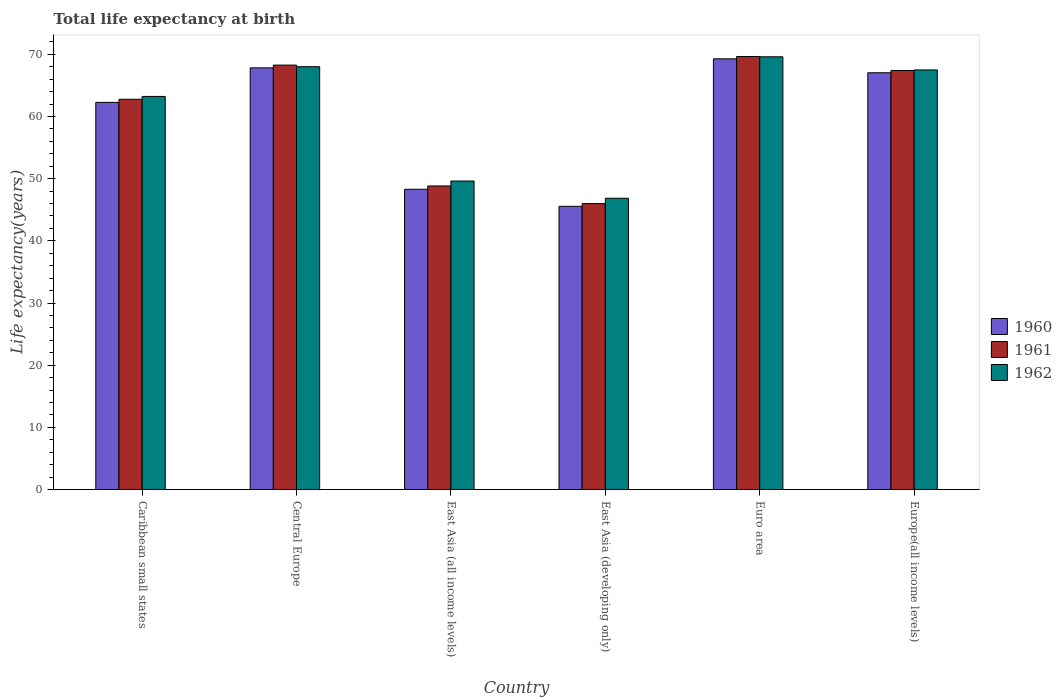Are the number of bars per tick equal to the number of legend labels?
Give a very brief answer. Yes. How many bars are there on the 4th tick from the left?
Offer a very short reply. 3. What is the label of the 2nd group of bars from the left?
Your answer should be compact. Central Europe. What is the life expectancy at birth in in 1961 in Euro area?
Give a very brief answer. 69.64. Across all countries, what is the maximum life expectancy at birth in in 1960?
Give a very brief answer. 69.27. Across all countries, what is the minimum life expectancy at birth in in 1962?
Offer a terse response. 46.85. In which country was the life expectancy at birth in in 1961 maximum?
Provide a short and direct response. Euro area. In which country was the life expectancy at birth in in 1961 minimum?
Keep it short and to the point. East Asia (developing only). What is the total life expectancy at birth in in 1962 in the graph?
Offer a terse response. 364.8. What is the difference between the life expectancy at birth in in 1960 in Caribbean small states and that in East Asia (developing only)?
Ensure brevity in your answer.  16.72. What is the difference between the life expectancy at birth in in 1961 in East Asia (all income levels) and the life expectancy at birth in in 1962 in Euro area?
Offer a very short reply. -20.78. What is the average life expectancy at birth in in 1962 per country?
Your answer should be compact. 60.8. What is the difference between the life expectancy at birth in of/in 1960 and life expectancy at birth in of/in 1961 in East Asia (developing only)?
Provide a succinct answer. -0.44. What is the ratio of the life expectancy at birth in in 1961 in Caribbean small states to that in Europe(all income levels)?
Offer a terse response. 0.93. Is the life expectancy at birth in in 1961 in East Asia (all income levels) less than that in Europe(all income levels)?
Your answer should be very brief. Yes. Is the difference between the life expectancy at birth in in 1960 in Caribbean small states and Euro area greater than the difference between the life expectancy at birth in in 1961 in Caribbean small states and Euro area?
Keep it short and to the point. No. What is the difference between the highest and the second highest life expectancy at birth in in 1962?
Offer a terse response. -0.52. What is the difference between the highest and the lowest life expectancy at birth in in 1961?
Keep it short and to the point. 23.66. In how many countries, is the life expectancy at birth in in 1960 greater than the average life expectancy at birth in in 1960 taken over all countries?
Your answer should be very brief. 4. Is the sum of the life expectancy at birth in in 1960 in East Asia (all income levels) and East Asia (developing only) greater than the maximum life expectancy at birth in in 1961 across all countries?
Provide a short and direct response. Yes. What does the 1st bar from the left in East Asia (all income levels) represents?
Ensure brevity in your answer.  1960. What does the 3rd bar from the right in East Asia (developing only) represents?
Give a very brief answer. 1960. How many bars are there?
Make the answer very short. 18. Are all the bars in the graph horizontal?
Your answer should be compact. No. Where does the legend appear in the graph?
Offer a terse response. Center right. How many legend labels are there?
Keep it short and to the point. 3. What is the title of the graph?
Provide a short and direct response. Total life expectancy at birth. What is the label or title of the Y-axis?
Provide a short and direct response. Life expectancy(years). What is the Life expectancy(years) of 1960 in Caribbean small states?
Give a very brief answer. 62.27. What is the Life expectancy(years) of 1961 in Caribbean small states?
Give a very brief answer. 62.77. What is the Life expectancy(years) in 1962 in Caribbean small states?
Offer a terse response. 63.23. What is the Life expectancy(years) of 1960 in Central Europe?
Ensure brevity in your answer.  67.82. What is the Life expectancy(years) of 1961 in Central Europe?
Make the answer very short. 68.26. What is the Life expectancy(years) of 1962 in Central Europe?
Ensure brevity in your answer.  68.01. What is the Life expectancy(years) in 1960 in East Asia (all income levels)?
Your answer should be very brief. 48.3. What is the Life expectancy(years) in 1961 in East Asia (all income levels)?
Make the answer very short. 48.82. What is the Life expectancy(years) in 1962 in East Asia (all income levels)?
Provide a succinct answer. 49.62. What is the Life expectancy(years) in 1960 in East Asia (developing only)?
Your response must be concise. 45.55. What is the Life expectancy(years) of 1961 in East Asia (developing only)?
Keep it short and to the point. 45.99. What is the Life expectancy(years) of 1962 in East Asia (developing only)?
Provide a short and direct response. 46.85. What is the Life expectancy(years) in 1960 in Euro area?
Give a very brief answer. 69.27. What is the Life expectancy(years) of 1961 in Euro area?
Your answer should be compact. 69.64. What is the Life expectancy(years) of 1962 in Euro area?
Keep it short and to the point. 69.6. What is the Life expectancy(years) in 1960 in Europe(all income levels)?
Keep it short and to the point. 67.03. What is the Life expectancy(years) of 1961 in Europe(all income levels)?
Your answer should be compact. 67.39. What is the Life expectancy(years) in 1962 in Europe(all income levels)?
Ensure brevity in your answer.  67.49. Across all countries, what is the maximum Life expectancy(years) in 1960?
Keep it short and to the point. 69.27. Across all countries, what is the maximum Life expectancy(years) of 1961?
Keep it short and to the point. 69.64. Across all countries, what is the maximum Life expectancy(years) of 1962?
Provide a short and direct response. 69.6. Across all countries, what is the minimum Life expectancy(years) in 1960?
Ensure brevity in your answer.  45.55. Across all countries, what is the minimum Life expectancy(years) of 1961?
Provide a succinct answer. 45.99. Across all countries, what is the minimum Life expectancy(years) of 1962?
Keep it short and to the point. 46.85. What is the total Life expectancy(years) in 1960 in the graph?
Make the answer very short. 360.25. What is the total Life expectancy(years) of 1961 in the graph?
Your answer should be very brief. 362.88. What is the total Life expectancy(years) in 1962 in the graph?
Make the answer very short. 364.8. What is the difference between the Life expectancy(years) in 1960 in Caribbean small states and that in Central Europe?
Provide a succinct answer. -5.55. What is the difference between the Life expectancy(years) of 1961 in Caribbean small states and that in Central Europe?
Your answer should be very brief. -5.49. What is the difference between the Life expectancy(years) of 1962 in Caribbean small states and that in Central Europe?
Your answer should be very brief. -4.78. What is the difference between the Life expectancy(years) of 1960 in Caribbean small states and that in East Asia (all income levels)?
Your response must be concise. 13.97. What is the difference between the Life expectancy(years) of 1961 in Caribbean small states and that in East Asia (all income levels)?
Ensure brevity in your answer.  13.95. What is the difference between the Life expectancy(years) in 1962 in Caribbean small states and that in East Asia (all income levels)?
Give a very brief answer. 13.61. What is the difference between the Life expectancy(years) in 1960 in Caribbean small states and that in East Asia (developing only)?
Provide a short and direct response. 16.72. What is the difference between the Life expectancy(years) of 1961 in Caribbean small states and that in East Asia (developing only)?
Keep it short and to the point. 16.78. What is the difference between the Life expectancy(years) in 1962 in Caribbean small states and that in East Asia (developing only)?
Give a very brief answer. 16.37. What is the difference between the Life expectancy(years) in 1960 in Caribbean small states and that in Euro area?
Your answer should be compact. -7. What is the difference between the Life expectancy(years) of 1961 in Caribbean small states and that in Euro area?
Make the answer very short. -6.88. What is the difference between the Life expectancy(years) of 1962 in Caribbean small states and that in Euro area?
Ensure brevity in your answer.  -6.38. What is the difference between the Life expectancy(years) of 1960 in Caribbean small states and that in Europe(all income levels)?
Keep it short and to the point. -4.76. What is the difference between the Life expectancy(years) in 1961 in Caribbean small states and that in Europe(all income levels)?
Your answer should be very brief. -4.63. What is the difference between the Life expectancy(years) of 1962 in Caribbean small states and that in Europe(all income levels)?
Provide a succinct answer. -4.26. What is the difference between the Life expectancy(years) in 1960 in Central Europe and that in East Asia (all income levels)?
Ensure brevity in your answer.  19.53. What is the difference between the Life expectancy(years) in 1961 in Central Europe and that in East Asia (all income levels)?
Offer a very short reply. 19.44. What is the difference between the Life expectancy(years) in 1962 in Central Europe and that in East Asia (all income levels)?
Your response must be concise. 18.39. What is the difference between the Life expectancy(years) of 1960 in Central Europe and that in East Asia (developing only)?
Offer a terse response. 22.27. What is the difference between the Life expectancy(years) of 1961 in Central Europe and that in East Asia (developing only)?
Your response must be concise. 22.28. What is the difference between the Life expectancy(years) of 1962 in Central Europe and that in East Asia (developing only)?
Keep it short and to the point. 21.16. What is the difference between the Life expectancy(years) of 1960 in Central Europe and that in Euro area?
Give a very brief answer. -1.45. What is the difference between the Life expectancy(years) of 1961 in Central Europe and that in Euro area?
Keep it short and to the point. -1.38. What is the difference between the Life expectancy(years) of 1962 in Central Europe and that in Euro area?
Ensure brevity in your answer.  -1.59. What is the difference between the Life expectancy(years) of 1960 in Central Europe and that in Europe(all income levels)?
Keep it short and to the point. 0.79. What is the difference between the Life expectancy(years) of 1961 in Central Europe and that in Europe(all income levels)?
Offer a terse response. 0.87. What is the difference between the Life expectancy(years) of 1962 in Central Europe and that in Europe(all income levels)?
Your answer should be compact. 0.52. What is the difference between the Life expectancy(years) of 1960 in East Asia (all income levels) and that in East Asia (developing only)?
Ensure brevity in your answer.  2.75. What is the difference between the Life expectancy(years) of 1961 in East Asia (all income levels) and that in East Asia (developing only)?
Keep it short and to the point. 2.84. What is the difference between the Life expectancy(years) of 1962 in East Asia (all income levels) and that in East Asia (developing only)?
Ensure brevity in your answer.  2.77. What is the difference between the Life expectancy(years) of 1960 in East Asia (all income levels) and that in Euro area?
Your answer should be compact. -20.98. What is the difference between the Life expectancy(years) in 1961 in East Asia (all income levels) and that in Euro area?
Ensure brevity in your answer.  -20.82. What is the difference between the Life expectancy(years) of 1962 in East Asia (all income levels) and that in Euro area?
Offer a terse response. -19.98. What is the difference between the Life expectancy(years) of 1960 in East Asia (all income levels) and that in Europe(all income levels)?
Ensure brevity in your answer.  -18.73. What is the difference between the Life expectancy(years) in 1961 in East Asia (all income levels) and that in Europe(all income levels)?
Ensure brevity in your answer.  -18.57. What is the difference between the Life expectancy(years) of 1962 in East Asia (all income levels) and that in Europe(all income levels)?
Provide a short and direct response. -17.87. What is the difference between the Life expectancy(years) in 1960 in East Asia (developing only) and that in Euro area?
Your answer should be compact. -23.72. What is the difference between the Life expectancy(years) in 1961 in East Asia (developing only) and that in Euro area?
Your answer should be very brief. -23.66. What is the difference between the Life expectancy(years) in 1962 in East Asia (developing only) and that in Euro area?
Offer a very short reply. -22.75. What is the difference between the Life expectancy(years) of 1960 in East Asia (developing only) and that in Europe(all income levels)?
Give a very brief answer. -21.48. What is the difference between the Life expectancy(years) in 1961 in East Asia (developing only) and that in Europe(all income levels)?
Offer a terse response. -21.41. What is the difference between the Life expectancy(years) of 1962 in East Asia (developing only) and that in Europe(all income levels)?
Give a very brief answer. -20.64. What is the difference between the Life expectancy(years) in 1960 in Euro area and that in Europe(all income levels)?
Your answer should be very brief. 2.24. What is the difference between the Life expectancy(years) of 1961 in Euro area and that in Europe(all income levels)?
Provide a succinct answer. 2.25. What is the difference between the Life expectancy(years) in 1962 in Euro area and that in Europe(all income levels)?
Offer a terse response. 2.11. What is the difference between the Life expectancy(years) in 1960 in Caribbean small states and the Life expectancy(years) in 1961 in Central Europe?
Keep it short and to the point. -5.99. What is the difference between the Life expectancy(years) of 1960 in Caribbean small states and the Life expectancy(years) of 1962 in Central Europe?
Keep it short and to the point. -5.74. What is the difference between the Life expectancy(years) of 1961 in Caribbean small states and the Life expectancy(years) of 1962 in Central Europe?
Ensure brevity in your answer.  -5.24. What is the difference between the Life expectancy(years) in 1960 in Caribbean small states and the Life expectancy(years) in 1961 in East Asia (all income levels)?
Offer a terse response. 13.45. What is the difference between the Life expectancy(years) of 1960 in Caribbean small states and the Life expectancy(years) of 1962 in East Asia (all income levels)?
Provide a short and direct response. 12.65. What is the difference between the Life expectancy(years) of 1961 in Caribbean small states and the Life expectancy(years) of 1962 in East Asia (all income levels)?
Your answer should be very brief. 13.15. What is the difference between the Life expectancy(years) in 1960 in Caribbean small states and the Life expectancy(years) in 1961 in East Asia (developing only)?
Give a very brief answer. 16.28. What is the difference between the Life expectancy(years) of 1960 in Caribbean small states and the Life expectancy(years) of 1962 in East Asia (developing only)?
Ensure brevity in your answer.  15.42. What is the difference between the Life expectancy(years) of 1961 in Caribbean small states and the Life expectancy(years) of 1962 in East Asia (developing only)?
Offer a very short reply. 15.92. What is the difference between the Life expectancy(years) of 1960 in Caribbean small states and the Life expectancy(years) of 1961 in Euro area?
Your answer should be compact. -7.37. What is the difference between the Life expectancy(years) in 1960 in Caribbean small states and the Life expectancy(years) in 1962 in Euro area?
Make the answer very short. -7.33. What is the difference between the Life expectancy(years) in 1961 in Caribbean small states and the Life expectancy(years) in 1962 in Euro area?
Offer a terse response. -6.83. What is the difference between the Life expectancy(years) of 1960 in Caribbean small states and the Life expectancy(years) of 1961 in Europe(all income levels)?
Give a very brief answer. -5.12. What is the difference between the Life expectancy(years) in 1960 in Caribbean small states and the Life expectancy(years) in 1962 in Europe(all income levels)?
Offer a very short reply. -5.22. What is the difference between the Life expectancy(years) of 1961 in Caribbean small states and the Life expectancy(years) of 1962 in Europe(all income levels)?
Keep it short and to the point. -4.72. What is the difference between the Life expectancy(years) in 1960 in Central Europe and the Life expectancy(years) in 1961 in East Asia (all income levels)?
Your response must be concise. 19. What is the difference between the Life expectancy(years) in 1960 in Central Europe and the Life expectancy(years) in 1962 in East Asia (all income levels)?
Ensure brevity in your answer.  18.2. What is the difference between the Life expectancy(years) of 1961 in Central Europe and the Life expectancy(years) of 1962 in East Asia (all income levels)?
Offer a terse response. 18.64. What is the difference between the Life expectancy(years) in 1960 in Central Europe and the Life expectancy(years) in 1961 in East Asia (developing only)?
Make the answer very short. 21.84. What is the difference between the Life expectancy(years) of 1960 in Central Europe and the Life expectancy(years) of 1962 in East Asia (developing only)?
Make the answer very short. 20.97. What is the difference between the Life expectancy(years) of 1961 in Central Europe and the Life expectancy(years) of 1962 in East Asia (developing only)?
Make the answer very short. 21.41. What is the difference between the Life expectancy(years) of 1960 in Central Europe and the Life expectancy(years) of 1961 in Euro area?
Your response must be concise. -1.82. What is the difference between the Life expectancy(years) in 1960 in Central Europe and the Life expectancy(years) in 1962 in Euro area?
Your response must be concise. -1.78. What is the difference between the Life expectancy(years) of 1961 in Central Europe and the Life expectancy(years) of 1962 in Euro area?
Ensure brevity in your answer.  -1.34. What is the difference between the Life expectancy(years) in 1960 in Central Europe and the Life expectancy(years) in 1961 in Europe(all income levels)?
Provide a short and direct response. 0.43. What is the difference between the Life expectancy(years) of 1960 in Central Europe and the Life expectancy(years) of 1962 in Europe(all income levels)?
Your answer should be compact. 0.33. What is the difference between the Life expectancy(years) in 1961 in Central Europe and the Life expectancy(years) in 1962 in Europe(all income levels)?
Your answer should be very brief. 0.77. What is the difference between the Life expectancy(years) in 1960 in East Asia (all income levels) and the Life expectancy(years) in 1961 in East Asia (developing only)?
Your answer should be compact. 2.31. What is the difference between the Life expectancy(years) in 1960 in East Asia (all income levels) and the Life expectancy(years) in 1962 in East Asia (developing only)?
Give a very brief answer. 1.45. What is the difference between the Life expectancy(years) in 1961 in East Asia (all income levels) and the Life expectancy(years) in 1962 in East Asia (developing only)?
Your response must be concise. 1.97. What is the difference between the Life expectancy(years) in 1960 in East Asia (all income levels) and the Life expectancy(years) in 1961 in Euro area?
Your answer should be compact. -21.35. What is the difference between the Life expectancy(years) of 1960 in East Asia (all income levels) and the Life expectancy(years) of 1962 in Euro area?
Provide a succinct answer. -21.3. What is the difference between the Life expectancy(years) of 1961 in East Asia (all income levels) and the Life expectancy(years) of 1962 in Euro area?
Offer a terse response. -20.78. What is the difference between the Life expectancy(years) of 1960 in East Asia (all income levels) and the Life expectancy(years) of 1961 in Europe(all income levels)?
Give a very brief answer. -19.1. What is the difference between the Life expectancy(years) of 1960 in East Asia (all income levels) and the Life expectancy(years) of 1962 in Europe(all income levels)?
Your answer should be very brief. -19.19. What is the difference between the Life expectancy(years) in 1961 in East Asia (all income levels) and the Life expectancy(years) in 1962 in Europe(all income levels)?
Your response must be concise. -18.67. What is the difference between the Life expectancy(years) in 1960 in East Asia (developing only) and the Life expectancy(years) in 1961 in Euro area?
Provide a succinct answer. -24.09. What is the difference between the Life expectancy(years) of 1960 in East Asia (developing only) and the Life expectancy(years) of 1962 in Euro area?
Make the answer very short. -24.05. What is the difference between the Life expectancy(years) of 1961 in East Asia (developing only) and the Life expectancy(years) of 1962 in Euro area?
Keep it short and to the point. -23.62. What is the difference between the Life expectancy(years) of 1960 in East Asia (developing only) and the Life expectancy(years) of 1961 in Europe(all income levels)?
Keep it short and to the point. -21.85. What is the difference between the Life expectancy(years) of 1960 in East Asia (developing only) and the Life expectancy(years) of 1962 in Europe(all income levels)?
Make the answer very short. -21.94. What is the difference between the Life expectancy(years) in 1961 in East Asia (developing only) and the Life expectancy(years) in 1962 in Europe(all income levels)?
Your response must be concise. -21.5. What is the difference between the Life expectancy(years) in 1960 in Euro area and the Life expectancy(years) in 1961 in Europe(all income levels)?
Offer a terse response. 1.88. What is the difference between the Life expectancy(years) in 1960 in Euro area and the Life expectancy(years) in 1962 in Europe(all income levels)?
Provide a short and direct response. 1.78. What is the difference between the Life expectancy(years) of 1961 in Euro area and the Life expectancy(years) of 1962 in Europe(all income levels)?
Provide a short and direct response. 2.15. What is the average Life expectancy(years) of 1960 per country?
Your answer should be compact. 60.04. What is the average Life expectancy(years) in 1961 per country?
Your answer should be compact. 60.48. What is the average Life expectancy(years) of 1962 per country?
Keep it short and to the point. 60.8. What is the difference between the Life expectancy(years) in 1960 and Life expectancy(years) in 1961 in Caribbean small states?
Offer a very short reply. -0.5. What is the difference between the Life expectancy(years) in 1960 and Life expectancy(years) in 1962 in Caribbean small states?
Provide a succinct answer. -0.95. What is the difference between the Life expectancy(years) in 1961 and Life expectancy(years) in 1962 in Caribbean small states?
Your answer should be very brief. -0.46. What is the difference between the Life expectancy(years) of 1960 and Life expectancy(years) of 1961 in Central Europe?
Your response must be concise. -0.44. What is the difference between the Life expectancy(years) of 1960 and Life expectancy(years) of 1962 in Central Europe?
Offer a very short reply. -0.18. What is the difference between the Life expectancy(years) in 1961 and Life expectancy(years) in 1962 in Central Europe?
Provide a succinct answer. 0.26. What is the difference between the Life expectancy(years) of 1960 and Life expectancy(years) of 1961 in East Asia (all income levels)?
Your answer should be compact. -0.53. What is the difference between the Life expectancy(years) of 1960 and Life expectancy(years) of 1962 in East Asia (all income levels)?
Keep it short and to the point. -1.32. What is the difference between the Life expectancy(years) of 1961 and Life expectancy(years) of 1962 in East Asia (all income levels)?
Provide a succinct answer. -0.8. What is the difference between the Life expectancy(years) of 1960 and Life expectancy(years) of 1961 in East Asia (developing only)?
Keep it short and to the point. -0.44. What is the difference between the Life expectancy(years) in 1960 and Life expectancy(years) in 1962 in East Asia (developing only)?
Keep it short and to the point. -1.3. What is the difference between the Life expectancy(years) of 1961 and Life expectancy(years) of 1962 in East Asia (developing only)?
Give a very brief answer. -0.86. What is the difference between the Life expectancy(years) in 1960 and Life expectancy(years) in 1961 in Euro area?
Give a very brief answer. -0.37. What is the difference between the Life expectancy(years) in 1960 and Life expectancy(years) in 1962 in Euro area?
Offer a very short reply. -0.33. What is the difference between the Life expectancy(years) of 1961 and Life expectancy(years) of 1962 in Euro area?
Your answer should be very brief. 0.04. What is the difference between the Life expectancy(years) of 1960 and Life expectancy(years) of 1961 in Europe(all income levels)?
Offer a terse response. -0.36. What is the difference between the Life expectancy(years) in 1960 and Life expectancy(years) in 1962 in Europe(all income levels)?
Keep it short and to the point. -0.46. What is the difference between the Life expectancy(years) of 1961 and Life expectancy(years) of 1962 in Europe(all income levels)?
Offer a terse response. -0.09. What is the ratio of the Life expectancy(years) of 1960 in Caribbean small states to that in Central Europe?
Keep it short and to the point. 0.92. What is the ratio of the Life expectancy(years) of 1961 in Caribbean small states to that in Central Europe?
Offer a terse response. 0.92. What is the ratio of the Life expectancy(years) in 1962 in Caribbean small states to that in Central Europe?
Provide a short and direct response. 0.93. What is the ratio of the Life expectancy(years) in 1960 in Caribbean small states to that in East Asia (all income levels)?
Provide a short and direct response. 1.29. What is the ratio of the Life expectancy(years) of 1961 in Caribbean small states to that in East Asia (all income levels)?
Keep it short and to the point. 1.29. What is the ratio of the Life expectancy(years) of 1962 in Caribbean small states to that in East Asia (all income levels)?
Offer a very short reply. 1.27. What is the ratio of the Life expectancy(years) in 1960 in Caribbean small states to that in East Asia (developing only)?
Make the answer very short. 1.37. What is the ratio of the Life expectancy(years) of 1961 in Caribbean small states to that in East Asia (developing only)?
Keep it short and to the point. 1.36. What is the ratio of the Life expectancy(years) of 1962 in Caribbean small states to that in East Asia (developing only)?
Provide a short and direct response. 1.35. What is the ratio of the Life expectancy(years) of 1960 in Caribbean small states to that in Euro area?
Ensure brevity in your answer.  0.9. What is the ratio of the Life expectancy(years) of 1961 in Caribbean small states to that in Euro area?
Offer a terse response. 0.9. What is the ratio of the Life expectancy(years) in 1962 in Caribbean small states to that in Euro area?
Make the answer very short. 0.91. What is the ratio of the Life expectancy(years) in 1960 in Caribbean small states to that in Europe(all income levels)?
Make the answer very short. 0.93. What is the ratio of the Life expectancy(years) in 1961 in Caribbean small states to that in Europe(all income levels)?
Offer a very short reply. 0.93. What is the ratio of the Life expectancy(years) in 1962 in Caribbean small states to that in Europe(all income levels)?
Offer a terse response. 0.94. What is the ratio of the Life expectancy(years) in 1960 in Central Europe to that in East Asia (all income levels)?
Your answer should be compact. 1.4. What is the ratio of the Life expectancy(years) of 1961 in Central Europe to that in East Asia (all income levels)?
Keep it short and to the point. 1.4. What is the ratio of the Life expectancy(years) in 1962 in Central Europe to that in East Asia (all income levels)?
Ensure brevity in your answer.  1.37. What is the ratio of the Life expectancy(years) in 1960 in Central Europe to that in East Asia (developing only)?
Offer a terse response. 1.49. What is the ratio of the Life expectancy(years) in 1961 in Central Europe to that in East Asia (developing only)?
Offer a terse response. 1.48. What is the ratio of the Life expectancy(years) in 1962 in Central Europe to that in East Asia (developing only)?
Make the answer very short. 1.45. What is the ratio of the Life expectancy(years) in 1960 in Central Europe to that in Euro area?
Your response must be concise. 0.98. What is the ratio of the Life expectancy(years) in 1961 in Central Europe to that in Euro area?
Keep it short and to the point. 0.98. What is the ratio of the Life expectancy(years) in 1962 in Central Europe to that in Euro area?
Offer a very short reply. 0.98. What is the ratio of the Life expectancy(years) of 1960 in Central Europe to that in Europe(all income levels)?
Ensure brevity in your answer.  1.01. What is the ratio of the Life expectancy(years) in 1961 in Central Europe to that in Europe(all income levels)?
Provide a short and direct response. 1.01. What is the ratio of the Life expectancy(years) in 1962 in Central Europe to that in Europe(all income levels)?
Keep it short and to the point. 1.01. What is the ratio of the Life expectancy(years) of 1960 in East Asia (all income levels) to that in East Asia (developing only)?
Make the answer very short. 1.06. What is the ratio of the Life expectancy(years) of 1961 in East Asia (all income levels) to that in East Asia (developing only)?
Keep it short and to the point. 1.06. What is the ratio of the Life expectancy(years) of 1962 in East Asia (all income levels) to that in East Asia (developing only)?
Offer a terse response. 1.06. What is the ratio of the Life expectancy(years) of 1960 in East Asia (all income levels) to that in Euro area?
Offer a very short reply. 0.7. What is the ratio of the Life expectancy(years) of 1961 in East Asia (all income levels) to that in Euro area?
Offer a terse response. 0.7. What is the ratio of the Life expectancy(years) of 1962 in East Asia (all income levels) to that in Euro area?
Your answer should be compact. 0.71. What is the ratio of the Life expectancy(years) of 1960 in East Asia (all income levels) to that in Europe(all income levels)?
Offer a terse response. 0.72. What is the ratio of the Life expectancy(years) of 1961 in East Asia (all income levels) to that in Europe(all income levels)?
Your response must be concise. 0.72. What is the ratio of the Life expectancy(years) of 1962 in East Asia (all income levels) to that in Europe(all income levels)?
Your response must be concise. 0.74. What is the ratio of the Life expectancy(years) of 1960 in East Asia (developing only) to that in Euro area?
Make the answer very short. 0.66. What is the ratio of the Life expectancy(years) of 1961 in East Asia (developing only) to that in Euro area?
Make the answer very short. 0.66. What is the ratio of the Life expectancy(years) of 1962 in East Asia (developing only) to that in Euro area?
Offer a terse response. 0.67. What is the ratio of the Life expectancy(years) in 1960 in East Asia (developing only) to that in Europe(all income levels)?
Your response must be concise. 0.68. What is the ratio of the Life expectancy(years) of 1961 in East Asia (developing only) to that in Europe(all income levels)?
Your response must be concise. 0.68. What is the ratio of the Life expectancy(years) in 1962 in East Asia (developing only) to that in Europe(all income levels)?
Your answer should be very brief. 0.69. What is the ratio of the Life expectancy(years) in 1960 in Euro area to that in Europe(all income levels)?
Give a very brief answer. 1.03. What is the ratio of the Life expectancy(years) of 1961 in Euro area to that in Europe(all income levels)?
Your answer should be compact. 1.03. What is the ratio of the Life expectancy(years) in 1962 in Euro area to that in Europe(all income levels)?
Ensure brevity in your answer.  1.03. What is the difference between the highest and the second highest Life expectancy(years) of 1960?
Ensure brevity in your answer.  1.45. What is the difference between the highest and the second highest Life expectancy(years) in 1961?
Offer a terse response. 1.38. What is the difference between the highest and the second highest Life expectancy(years) of 1962?
Ensure brevity in your answer.  1.59. What is the difference between the highest and the lowest Life expectancy(years) of 1960?
Provide a short and direct response. 23.72. What is the difference between the highest and the lowest Life expectancy(years) of 1961?
Your answer should be very brief. 23.66. What is the difference between the highest and the lowest Life expectancy(years) of 1962?
Offer a very short reply. 22.75. 